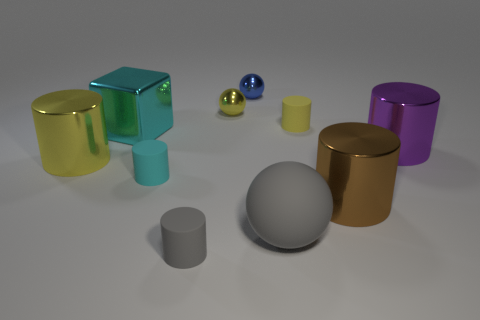How many other things are the same shape as the purple metallic object?
Your response must be concise. 5. Is the number of rubber objects that are in front of the cyan matte cylinder the same as the number of tiny cyan cylinders in front of the gray cylinder?
Ensure brevity in your answer.  No. Is the yellow cylinder that is left of the cyan block made of the same material as the tiny cylinder behind the cyan rubber thing?
Provide a succinct answer. No. How many other objects are there of the same size as the gray matte sphere?
Ensure brevity in your answer.  4. How many things are blue things or shiny objects behind the large brown thing?
Your answer should be compact. 5. Are there an equal number of small metallic things that are on the right side of the small yellow cylinder and cyan cubes?
Provide a short and direct response. No. What is the shape of the large purple object that is made of the same material as the tiny blue sphere?
Make the answer very short. Cylinder. Are there any large matte balls of the same color as the large cube?
Keep it short and to the point. No. What number of metal things are yellow things or tiny yellow spheres?
Give a very brief answer. 2. There is a shiny thing that is right of the brown thing; what number of small metal balls are behind it?
Ensure brevity in your answer.  2. 